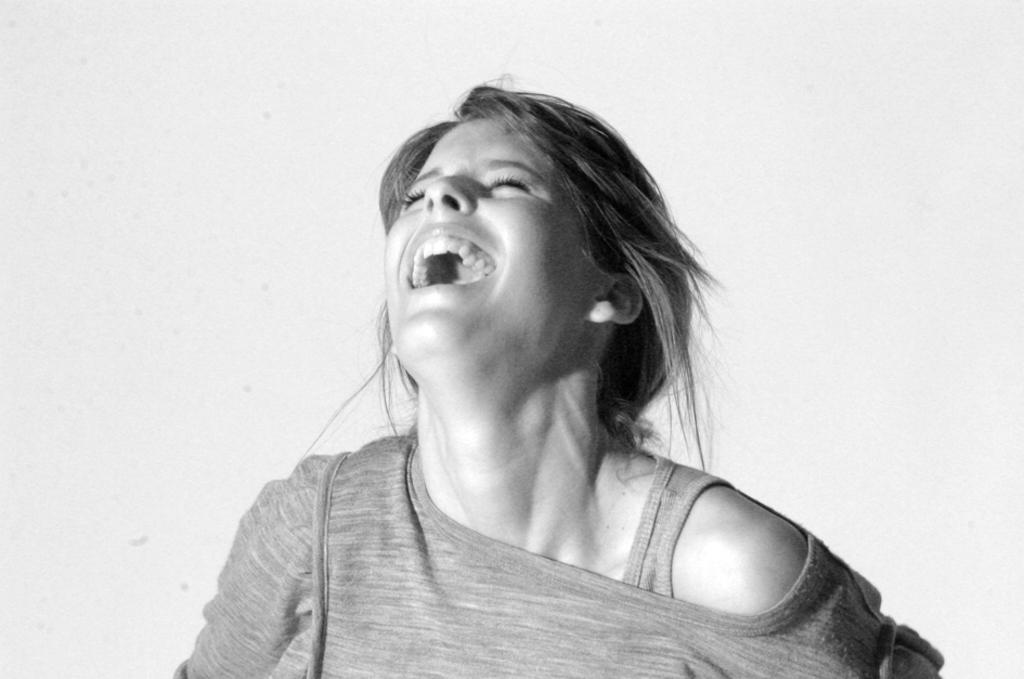Could you give a brief overview of what you see in this image? This is a black and white pic and we can see a woman is smiling. 